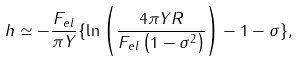<formula> <loc_0><loc_0><loc_500><loc_500>h \simeq - \frac { F _ { e l } } { \pi Y } \{ \ln \left ( \frac { 4 \pi Y R } { F _ { e l } \left ( 1 - \sigma ^ { 2 } \right ) } \right ) - 1 - \sigma \} ,</formula> 